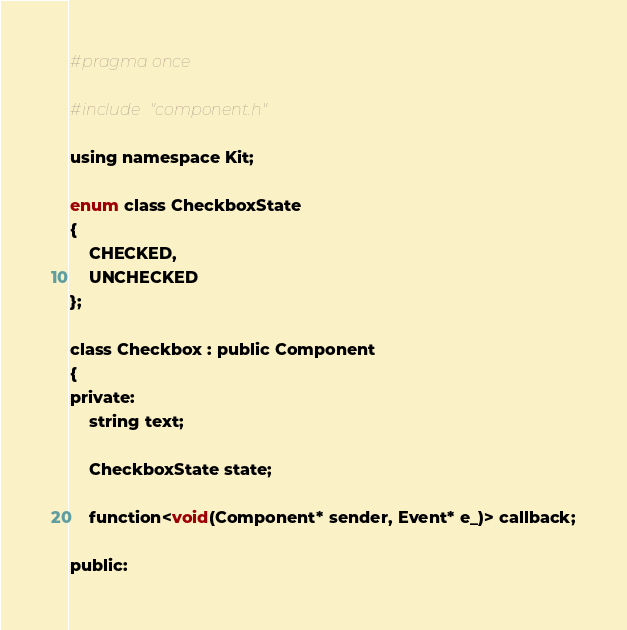<code> <loc_0><loc_0><loc_500><loc_500><_C_>#pragma once

#include "component.h"

using namespace Kit;

enum class CheckboxState
{
    CHECKED,
    UNCHECKED
};

class Checkbox : public Component
{
private:
    string text;

    CheckboxState state;

    function<void(Component* sender, Event* e_)> callback;

public:</code> 